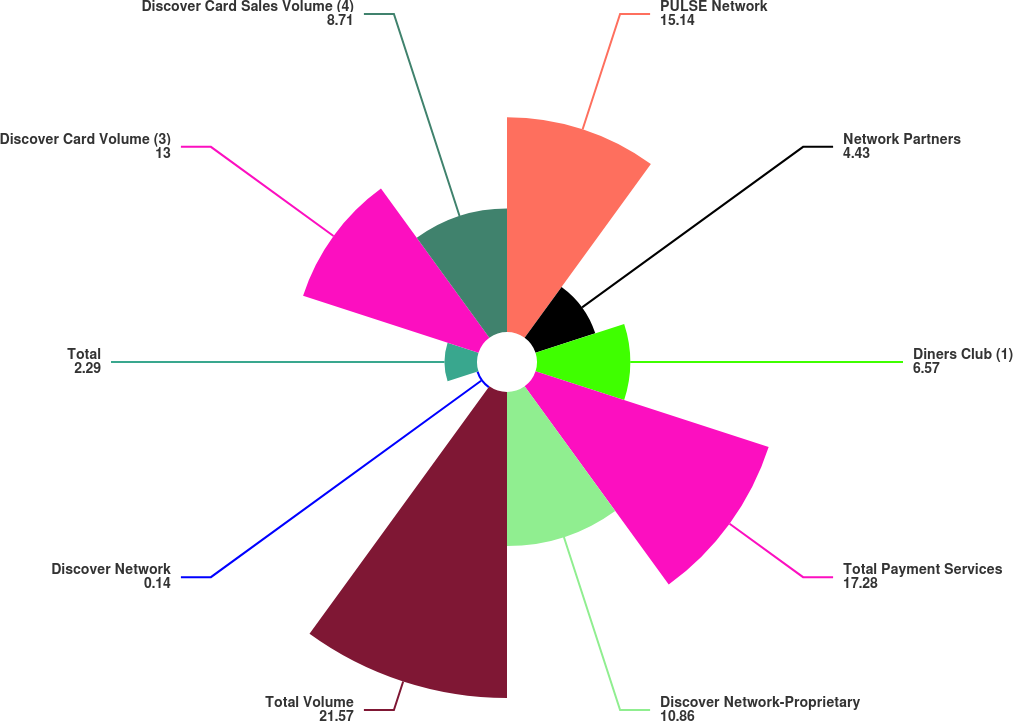<chart> <loc_0><loc_0><loc_500><loc_500><pie_chart><fcel>PULSE Network<fcel>Network Partners<fcel>Diners Club (1)<fcel>Total Payment Services<fcel>Discover Network-Proprietary<fcel>Total Volume<fcel>Discover Network<fcel>Total<fcel>Discover Card Volume (3)<fcel>Discover Card Sales Volume (4)<nl><fcel>15.14%<fcel>4.43%<fcel>6.57%<fcel>17.28%<fcel>10.86%<fcel>21.57%<fcel>0.14%<fcel>2.29%<fcel>13.0%<fcel>8.71%<nl></chart> 